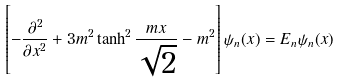<formula> <loc_0><loc_0><loc_500><loc_500>\left [ - \frac { \partial ^ { 2 } } { \partial x ^ { 2 } } + 3 m ^ { 2 } \tanh ^ { 2 } \frac { m x } { \sqrt { 2 } } - m ^ { 2 } \right ] \psi _ { n } ( x ) = E _ { n } \psi _ { n } ( x )</formula> 